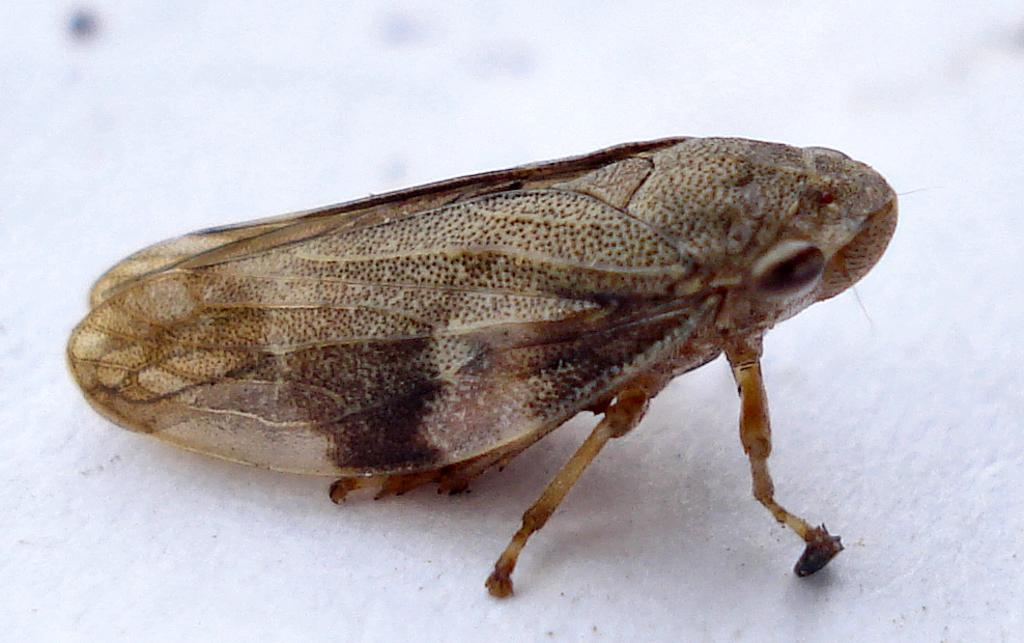What type of creature is present in the image? There is an insect in the image. Where is the insect located in the image? The insect is on the floor. What type of metal is the bat made of in the image? There is no bat present in the image, and therefore no metal can be associated with it. 